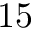<formula> <loc_0><loc_0><loc_500><loc_500>1 5</formula> 